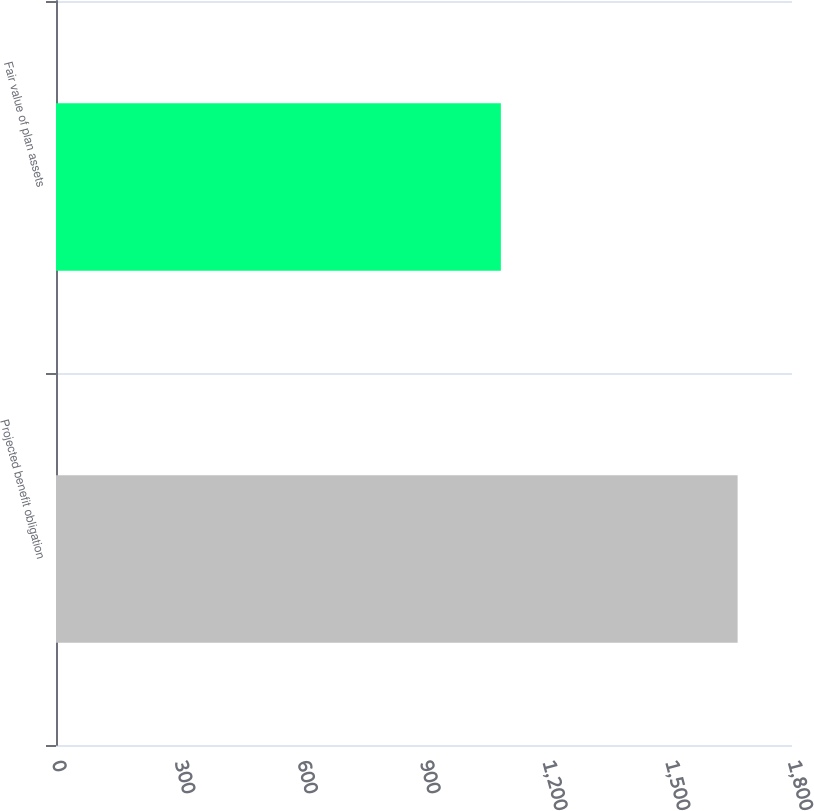Convert chart to OTSL. <chart><loc_0><loc_0><loc_500><loc_500><bar_chart><fcel>Projected benefit obligation<fcel>Fair value of plan assets<nl><fcel>1667<fcel>1088<nl></chart> 